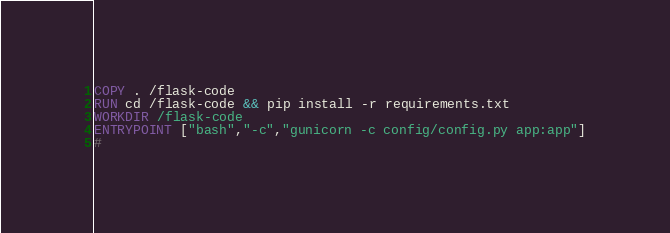Convert code to text. <code><loc_0><loc_0><loc_500><loc_500><_Dockerfile_>COPY . /flask-code
RUN cd /flask-code && pip install -r requirements.txt
WORKDIR /flask-code
ENTRYPOINT ["bash","-c","gunicorn -c config/config.py app:app"]
# </code> 